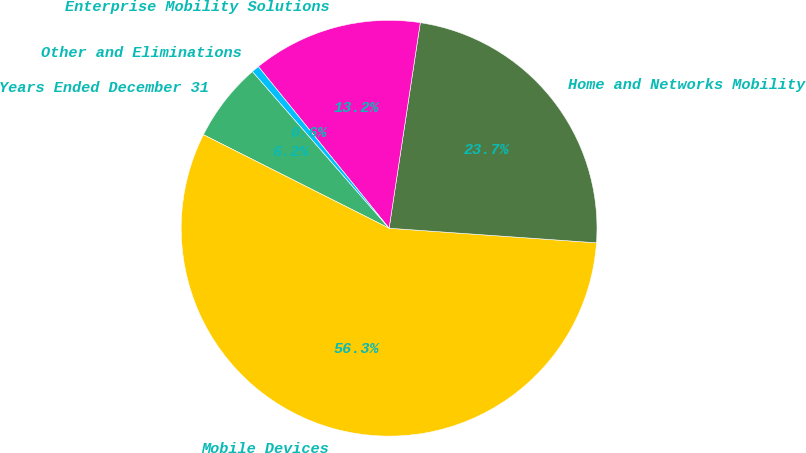Convert chart. <chart><loc_0><loc_0><loc_500><loc_500><pie_chart><fcel>Years Ended December 31<fcel>Mobile Devices<fcel>Home and Networks Mobility<fcel>Enterprise Mobility Solutions<fcel>Other and Eliminations<nl><fcel>6.16%<fcel>56.31%<fcel>23.72%<fcel>13.22%<fcel>0.59%<nl></chart> 